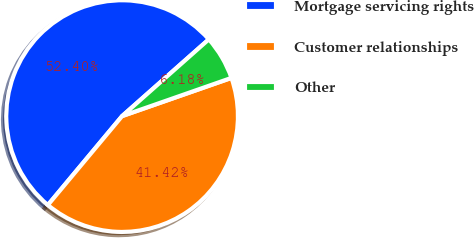<chart> <loc_0><loc_0><loc_500><loc_500><pie_chart><fcel>Mortgage servicing rights<fcel>Customer relationships<fcel>Other<nl><fcel>52.4%<fcel>41.42%<fcel>6.18%<nl></chart> 